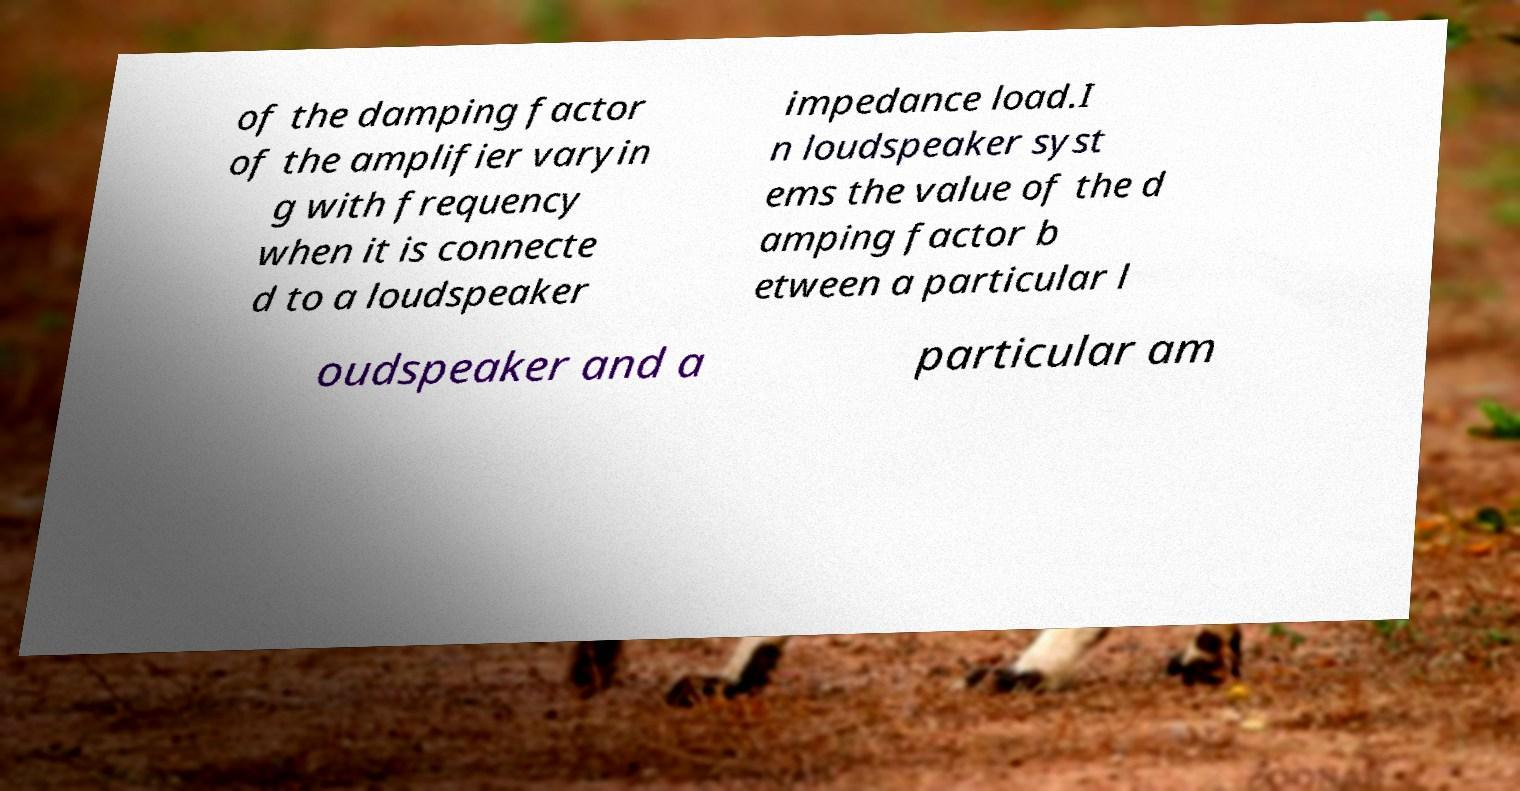Please read and relay the text visible in this image. What does it say? of the damping factor of the amplifier varyin g with frequency when it is connecte d to a loudspeaker impedance load.I n loudspeaker syst ems the value of the d amping factor b etween a particular l oudspeaker and a particular am 